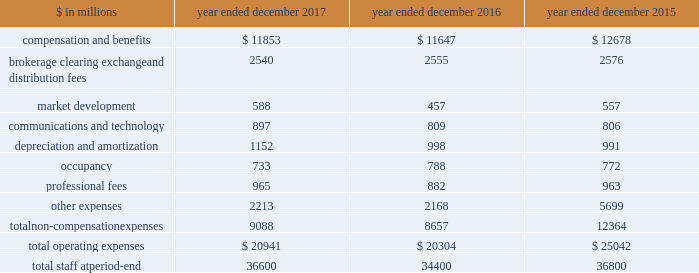The goldman sachs group , inc .
And subsidiaries management 2019s discussion and analysis other principal transactions revenues in the consolidated statements of earnings were $ 3.20 billion for 2016 , 36% ( 36 % ) lower than 2015 , primarily due to significantly lower revenues from investments in equities , primarily reflecting a significant decrease in net gains from private equities , driven by company-specific events and corporate performance .
In addition , revenues in debt securities and loans were significantly lower compared with 2015 , reflecting significantly lower revenues related to relationship lending activities , due to the impact of changes in credit spreads on economic hedges .
Losses related to these hedges were $ 596 million in 2016 , compared with gains of $ 329 million in 2015 .
This decrease was partially offset by higher net gains from investments in debt instruments .
See note 9 to the consolidated financial statements for further information about economic hedges related to our relationship lending activities .
Net interest income .
Net interest income in the consolidated statements of earnings was $ 2.59 billion for 2016 , 16% ( 16 % ) lower than 2015 , reflecting an increase in interest expense primarily due to the impact of higher interest rates on other interest-bearing liabilities , interest- bearing deposits and collateralized financings , and increases in total average long-term borrowings and total average interest-bearing deposits .
The increase in interest expense was partially offset by higher interest income related to collateralized agreements , reflecting the impact of higher interest rates , and loans receivable , reflecting an increase in total average balances and the impact of higher interest rates .
See 201cstatistical disclosures 2014 distribution of assets , liabilities and shareholders 2019 equity 201d for further information about our sources of net interest income .
Operating expenses our operating expenses are primarily influenced by compensation , headcount and levels of business activity .
Compensation and benefits includes salaries , discretionary compensation , amortization of equity awards and other items such as benefits .
Discretionary compensation is significantly impacted by , among other factors , the level of net revenues , overall financial performance , prevailing labor markets , business mix , the structure of our share- based compensation programs and the external environment .
In addition , see 201cuse of estimates 201d for further information about expenses that may arise from litigation and regulatory proceedings .
In the context of the challenging environment , we completed an initiative during 2016 that identified areas where we can operate more efficiently , resulting in a reduction of approximately $ 900 million in annual run rate compensation .
For 2016 , net savings from this initiative , after severance and other related costs , were approximately $ 500 million .
The table below presents our operating expenses and total staff ( including employees , consultants and temporary staff ) . .
In the table above , other expenses for 2015 included $ 3.37 billion recorded for the settlement agreement with the rmbs working group .
See note 27 to the consolidated financial statements in part ii , item 8 of our annual report on form 10-k for the year ended december 31 , 2015 for further information .
2017 versus 2016 .
Operating expenses in the consolidated statements of earnings were $ 20.94 billion for 2017 , 3% ( 3 % ) higher than 2016 .
Compensation and benefits expenses in the consolidated statements of earnings were $ 11.85 billion for 2017 , 2% ( 2 % ) higher than 2016 .
The ratio of compensation and benefits to net revenues for 2017 was 37.0% ( 37.0 % ) compared with 38.1% ( 38.1 % ) for 2016 .
Non-compensation expenses in the consolidated statements of earnings were $ 9.09 billion for 2017 , 5% ( 5 % ) higher than 2016 , primarily driven by our investments to fund growth .
The increase compared with 2016 reflected higher expenses related to consolidated investments and our digital lending and deposit platform , marcus : by goldman sachs ( marcus ) .
These increases were primarily included in depreciation and amortization expenses , market development expenses and other expenses .
In addition , technology expenses increased , reflecting higher expenses related to cloud-based services and software depreciation , and professional fees increased , primarily related to consulting costs .
These increases were partially offset by lower net provisions for litigation and regulatory proceedings , and lower occupancy expenses ( primarily related to exit costs in 2016 ) .
Net provisions for litigation and regulatory proceedings for 2017 were $ 188 million compared with $ 396 million for 2016 .
2017 included a $ 127 million charitable contribution to goldman sachs gives , our donor-advised fund .
Compensation was reduced to fund this charitable contribution to goldman sachs gives .
We ask our participating managing directors to make recommendations regarding potential charitable recipients for this contribution .
54 goldman sachs 2017 form 10-k .
What portion of total operating expenses is related to compensation and benefits in 2017? 
Computations: (11853 / 20941)
Answer: 0.56602. 